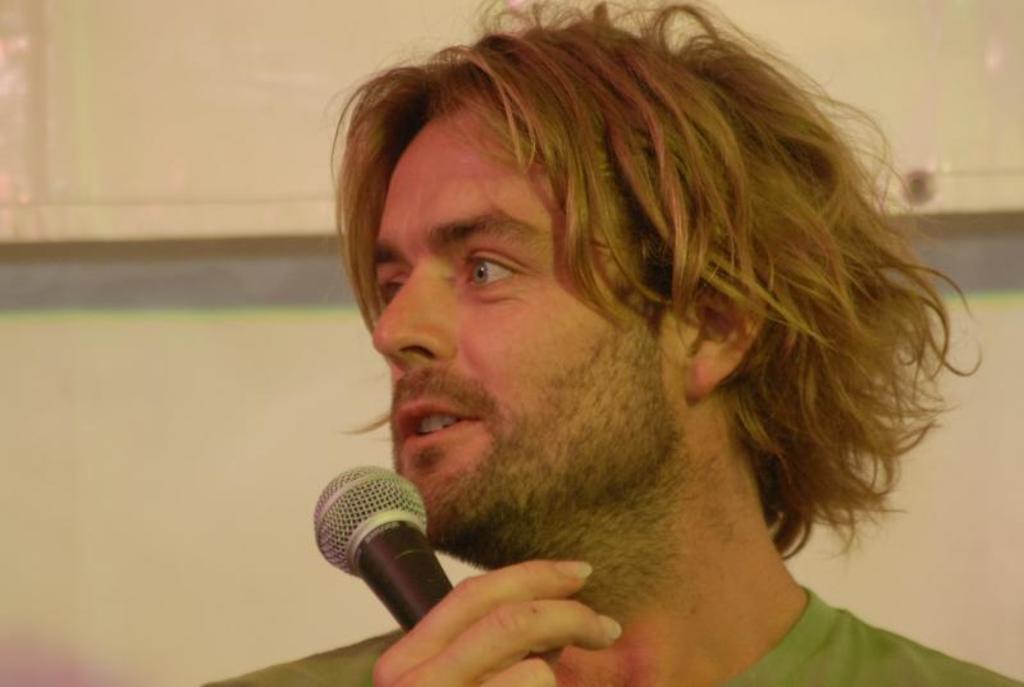Can you describe this image briefly? In this picture I can see a man is holding a microphone in the hand. In the background I can see wall. The man is wearing green color cloth. 